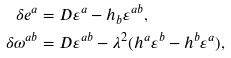Convert formula to latex. <formula><loc_0><loc_0><loc_500><loc_500>\delta e ^ { a } & = D \varepsilon ^ { a } - h _ { b } \varepsilon ^ { a b } , \\ \delta \omega ^ { a b } & = D \varepsilon ^ { a b } - \lambda ^ { 2 } ( h ^ { a } \varepsilon ^ { b } - h ^ { b } \varepsilon ^ { a } ) ,</formula> 